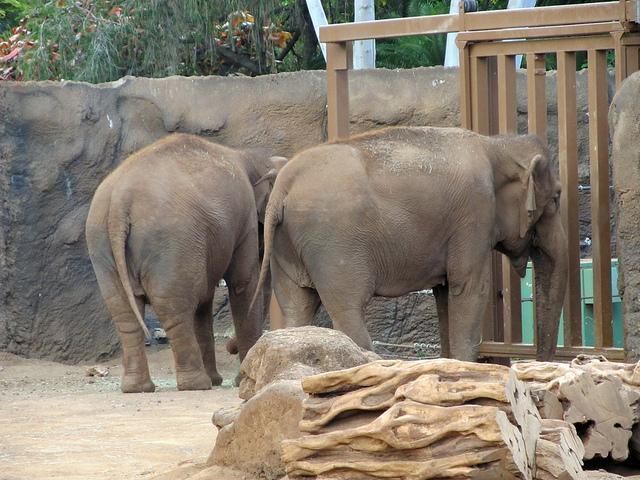How many elephants can you see?
Give a very brief answer. 2. How many elephants are in the picture?
Give a very brief answer. 2. How many giraffes are there?
Give a very brief answer. 0. 